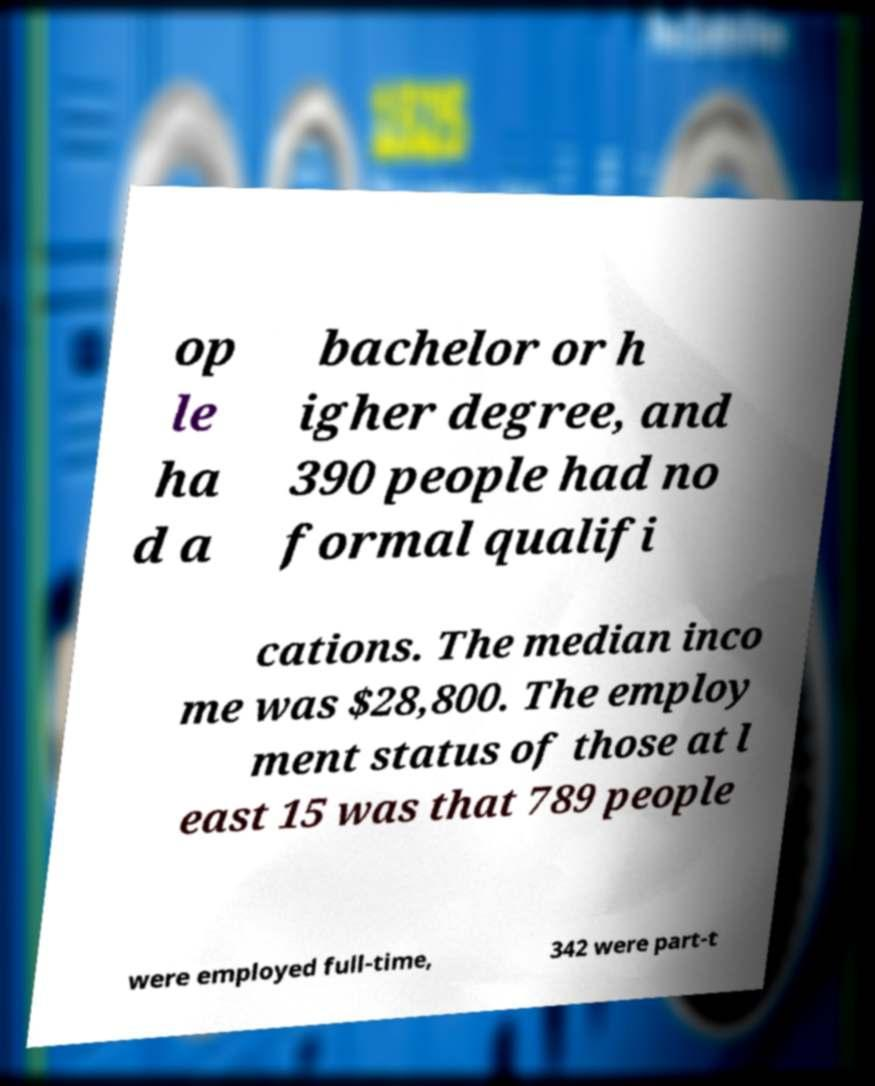Could you extract and type out the text from this image? op le ha d a bachelor or h igher degree, and 390 people had no formal qualifi cations. The median inco me was $28,800. The employ ment status of those at l east 15 was that 789 people were employed full-time, 342 were part-t 